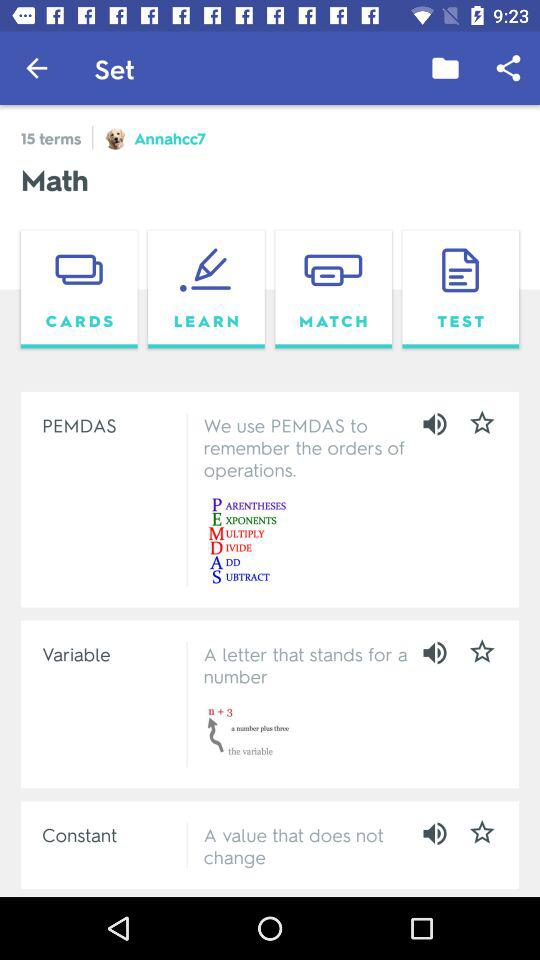What is the username? The username is "Annahcc7". 